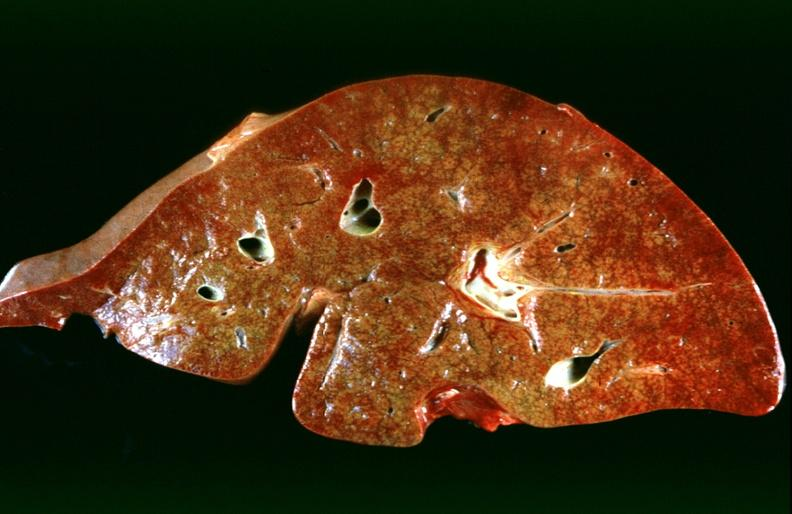what is present?
Answer the question using a single word or phrase. Hepatobiliary 